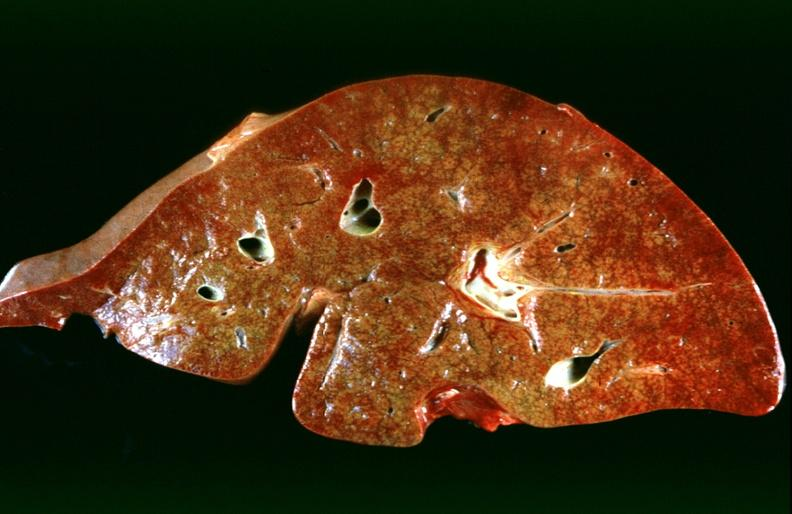what is present?
Answer the question using a single word or phrase. Hepatobiliary 